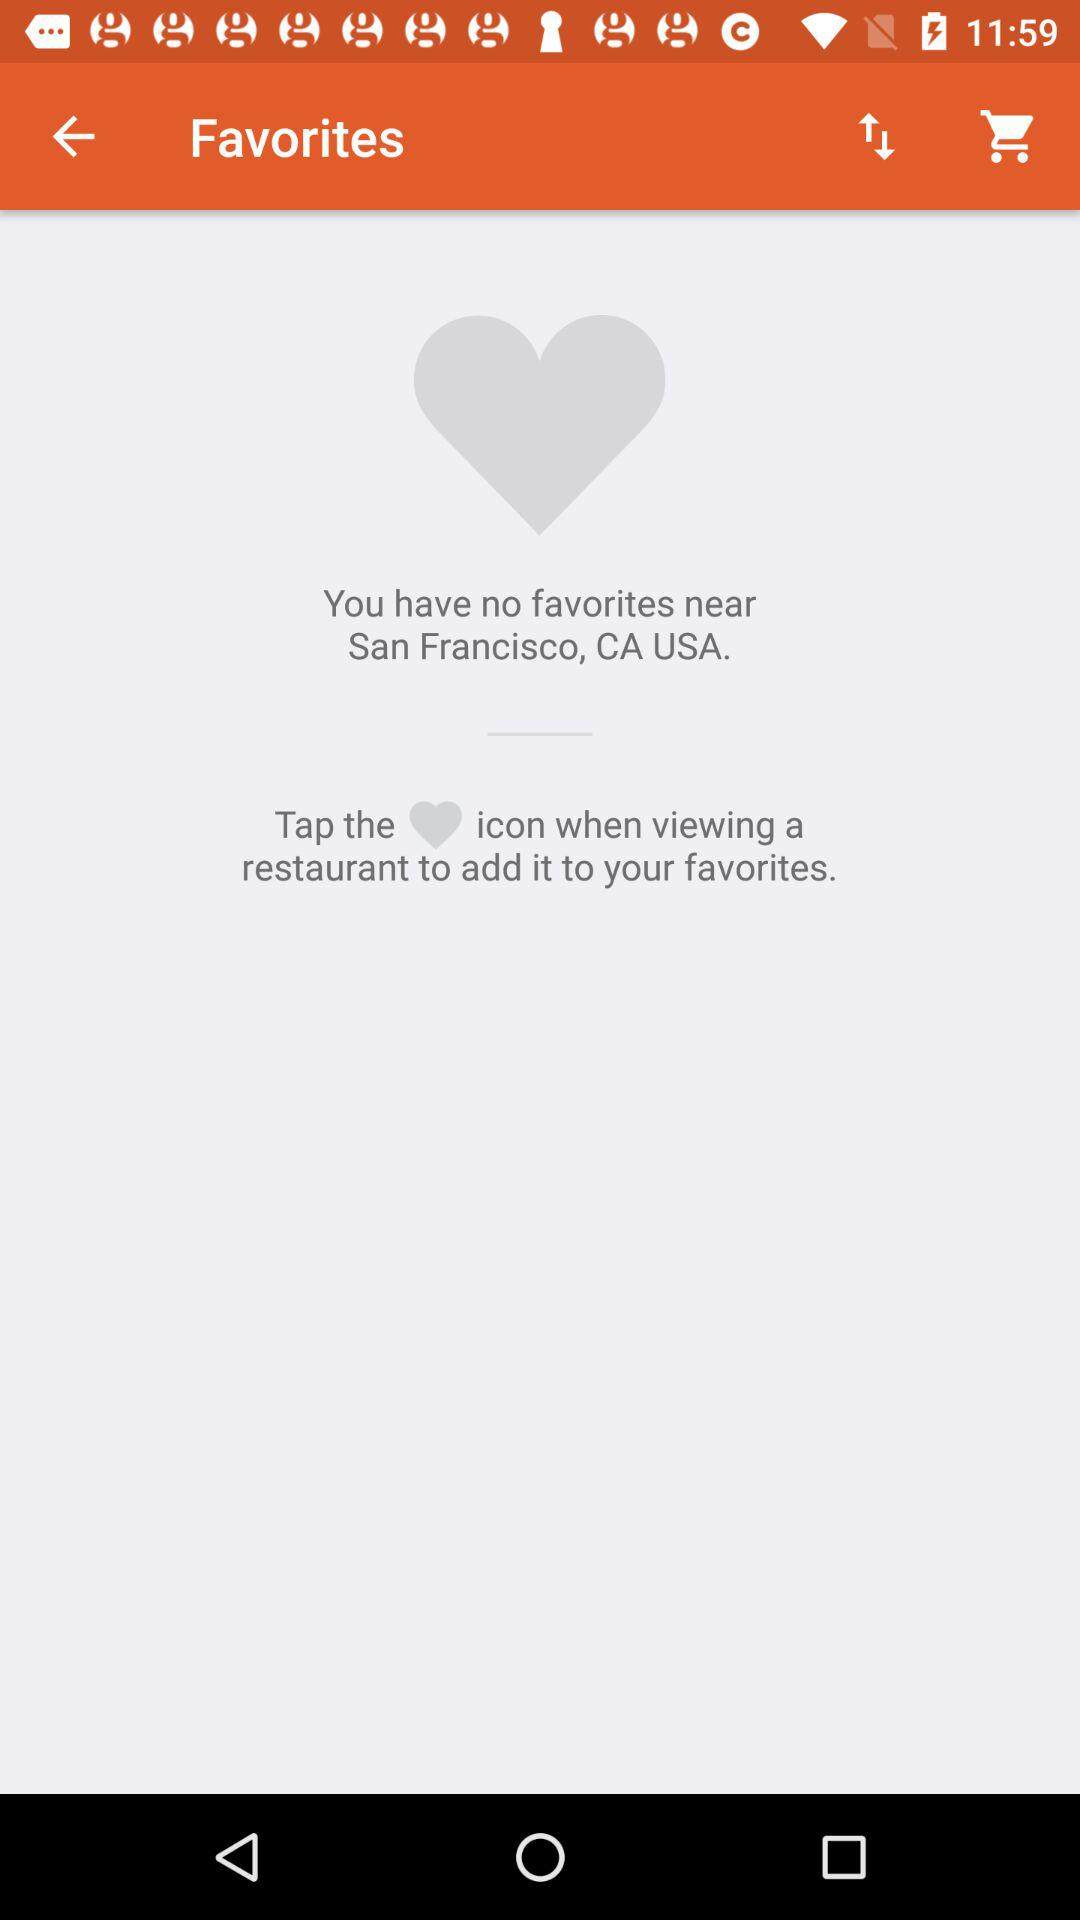What is the mentioned location? The mentioned location is San Francisco, CA, USA. 